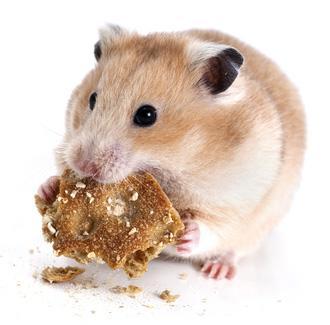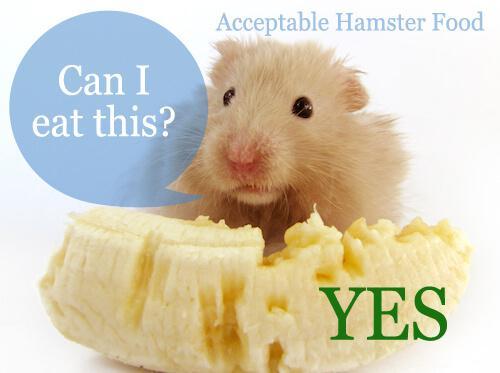The first image is the image on the left, the second image is the image on the right. For the images displayed, is the sentence "The food in the left image is green in color." factually correct? Answer yes or no. No. 